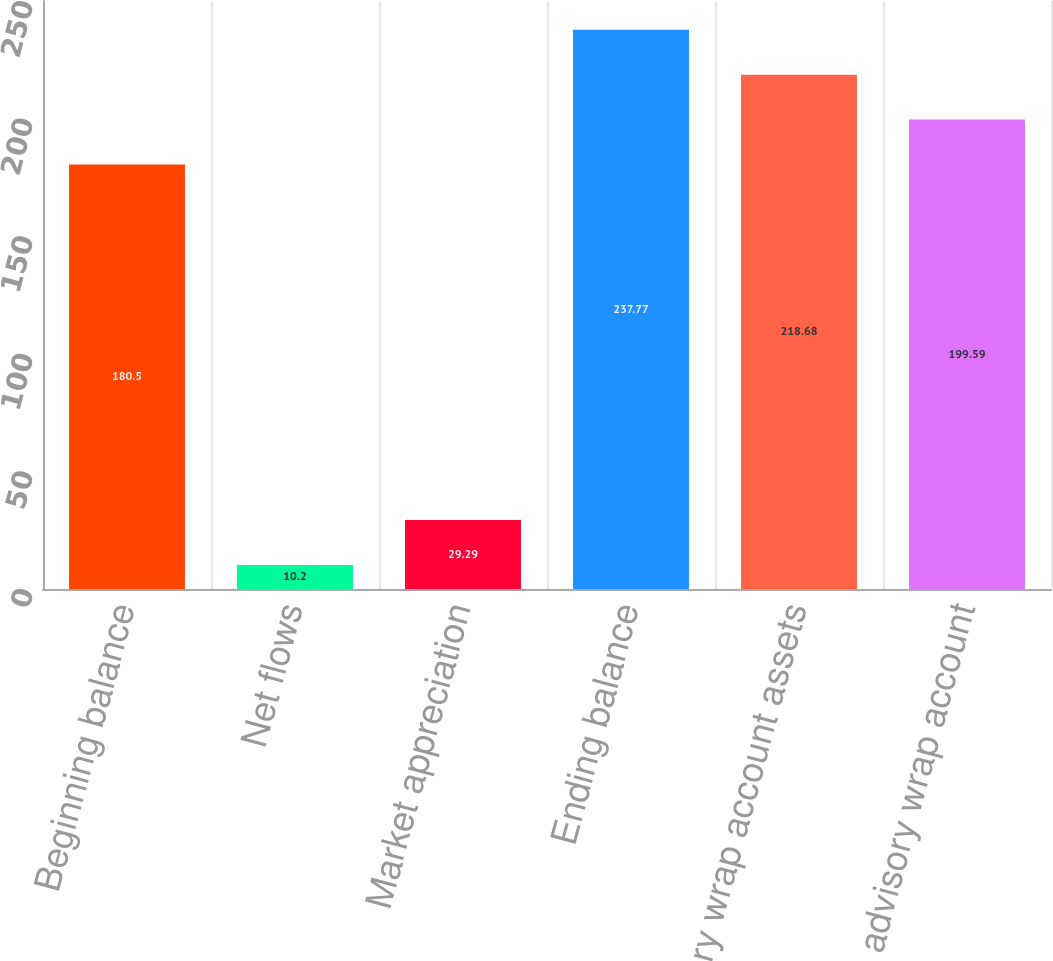Convert chart to OTSL. <chart><loc_0><loc_0><loc_500><loc_500><bar_chart><fcel>Beginning balance<fcel>Net flows<fcel>Market appreciation<fcel>Ending balance<fcel>Advisory wrap account assets<fcel>Average advisory wrap account<nl><fcel>180.5<fcel>10.2<fcel>29.29<fcel>237.77<fcel>218.68<fcel>199.59<nl></chart> 